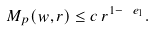<formula> <loc_0><loc_0><loc_500><loc_500>M _ { p } ( w , r ) \leq c \, r ^ { 1 - \ e _ { 1 } } .</formula> 